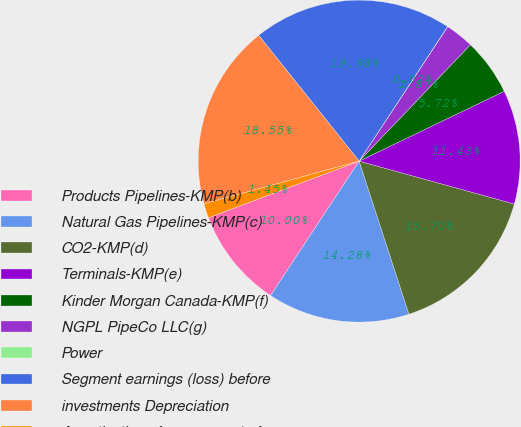Convert chart. <chart><loc_0><loc_0><loc_500><loc_500><pie_chart><fcel>Products Pipelines-KMP(b)<fcel>Natural Gas Pipelines-KMP(c)<fcel>CO2-KMP(d)<fcel>Terminals-KMP(e)<fcel>Kinder Morgan Canada-KMP(f)<fcel>NGPL PipeCo LLC(g)<fcel>Power<fcel>Segment earnings (loss) before<fcel>investments Depreciation<fcel>Amortization of excess cost of<nl><fcel>10.0%<fcel>14.28%<fcel>15.7%<fcel>11.43%<fcel>5.72%<fcel>2.87%<fcel>0.02%<fcel>19.98%<fcel>18.55%<fcel>1.45%<nl></chart> 